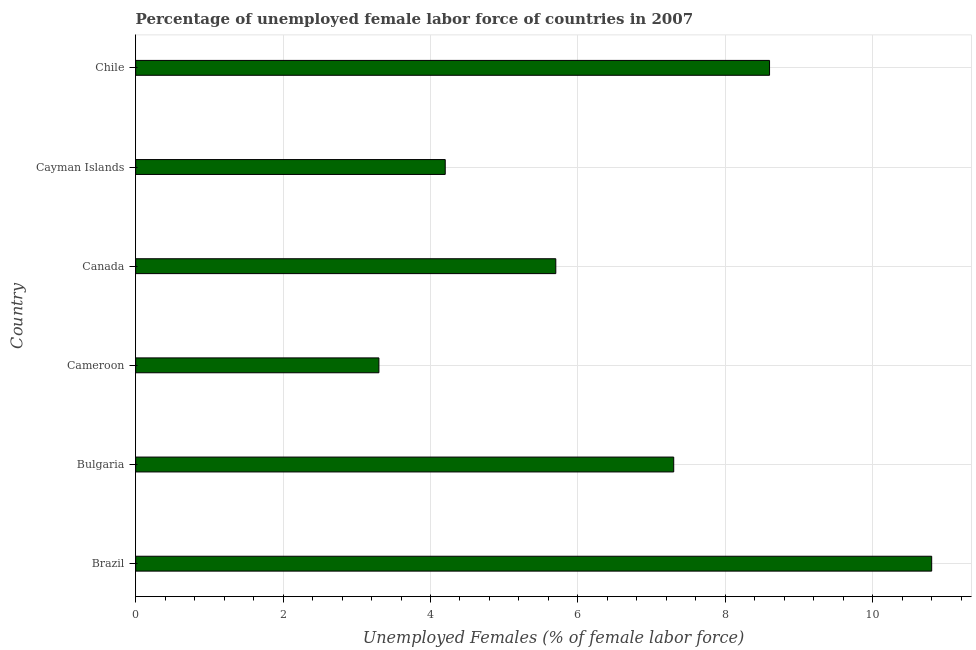Does the graph contain any zero values?
Offer a terse response. No. Does the graph contain grids?
Make the answer very short. Yes. What is the title of the graph?
Provide a succinct answer. Percentage of unemployed female labor force of countries in 2007. What is the label or title of the X-axis?
Ensure brevity in your answer.  Unemployed Females (% of female labor force). What is the label or title of the Y-axis?
Your answer should be very brief. Country. What is the total unemployed female labour force in Bulgaria?
Keep it short and to the point. 7.3. Across all countries, what is the maximum total unemployed female labour force?
Give a very brief answer. 10.8. Across all countries, what is the minimum total unemployed female labour force?
Ensure brevity in your answer.  3.3. In which country was the total unemployed female labour force maximum?
Give a very brief answer. Brazil. In which country was the total unemployed female labour force minimum?
Give a very brief answer. Cameroon. What is the sum of the total unemployed female labour force?
Ensure brevity in your answer.  39.9. What is the average total unemployed female labour force per country?
Your answer should be compact. 6.65. What is the median total unemployed female labour force?
Keep it short and to the point. 6.5. What is the ratio of the total unemployed female labour force in Bulgaria to that in Chile?
Give a very brief answer. 0.85. What is the difference between the highest and the second highest total unemployed female labour force?
Provide a succinct answer. 2.2. Is the sum of the total unemployed female labour force in Cameroon and Chile greater than the maximum total unemployed female labour force across all countries?
Provide a short and direct response. Yes. In how many countries, is the total unemployed female labour force greater than the average total unemployed female labour force taken over all countries?
Provide a short and direct response. 3. How many bars are there?
Your answer should be compact. 6. Are all the bars in the graph horizontal?
Offer a terse response. Yes. How many countries are there in the graph?
Offer a very short reply. 6. Are the values on the major ticks of X-axis written in scientific E-notation?
Offer a very short reply. No. What is the Unemployed Females (% of female labor force) in Brazil?
Your response must be concise. 10.8. What is the Unemployed Females (% of female labor force) of Bulgaria?
Provide a short and direct response. 7.3. What is the Unemployed Females (% of female labor force) of Cameroon?
Make the answer very short. 3.3. What is the Unemployed Females (% of female labor force) in Canada?
Provide a succinct answer. 5.7. What is the Unemployed Females (% of female labor force) in Cayman Islands?
Offer a very short reply. 4.2. What is the Unemployed Females (% of female labor force) of Chile?
Give a very brief answer. 8.6. What is the difference between the Unemployed Females (% of female labor force) in Brazil and Bulgaria?
Your response must be concise. 3.5. What is the difference between the Unemployed Females (% of female labor force) in Brazil and Cameroon?
Keep it short and to the point. 7.5. What is the difference between the Unemployed Females (% of female labor force) in Brazil and Cayman Islands?
Your response must be concise. 6.6. What is the difference between the Unemployed Females (% of female labor force) in Brazil and Chile?
Offer a terse response. 2.2. What is the difference between the Unemployed Females (% of female labor force) in Bulgaria and Canada?
Ensure brevity in your answer.  1.6. What is the difference between the Unemployed Females (% of female labor force) in Cameroon and Canada?
Give a very brief answer. -2.4. What is the difference between the Unemployed Females (% of female labor force) in Cameroon and Cayman Islands?
Give a very brief answer. -0.9. What is the difference between the Unemployed Females (% of female labor force) in Cameroon and Chile?
Keep it short and to the point. -5.3. What is the difference between the Unemployed Females (% of female labor force) in Canada and Cayman Islands?
Provide a succinct answer. 1.5. What is the difference between the Unemployed Females (% of female labor force) in Canada and Chile?
Offer a very short reply. -2.9. What is the difference between the Unemployed Females (% of female labor force) in Cayman Islands and Chile?
Keep it short and to the point. -4.4. What is the ratio of the Unemployed Females (% of female labor force) in Brazil to that in Bulgaria?
Offer a terse response. 1.48. What is the ratio of the Unemployed Females (% of female labor force) in Brazil to that in Cameroon?
Make the answer very short. 3.27. What is the ratio of the Unemployed Females (% of female labor force) in Brazil to that in Canada?
Offer a terse response. 1.9. What is the ratio of the Unemployed Females (% of female labor force) in Brazil to that in Cayman Islands?
Offer a very short reply. 2.57. What is the ratio of the Unemployed Females (% of female labor force) in Brazil to that in Chile?
Provide a short and direct response. 1.26. What is the ratio of the Unemployed Females (% of female labor force) in Bulgaria to that in Cameroon?
Your answer should be very brief. 2.21. What is the ratio of the Unemployed Females (% of female labor force) in Bulgaria to that in Canada?
Your response must be concise. 1.28. What is the ratio of the Unemployed Females (% of female labor force) in Bulgaria to that in Cayman Islands?
Your response must be concise. 1.74. What is the ratio of the Unemployed Females (% of female labor force) in Bulgaria to that in Chile?
Make the answer very short. 0.85. What is the ratio of the Unemployed Females (% of female labor force) in Cameroon to that in Canada?
Your answer should be very brief. 0.58. What is the ratio of the Unemployed Females (% of female labor force) in Cameroon to that in Cayman Islands?
Make the answer very short. 0.79. What is the ratio of the Unemployed Females (% of female labor force) in Cameroon to that in Chile?
Your answer should be compact. 0.38. What is the ratio of the Unemployed Females (% of female labor force) in Canada to that in Cayman Islands?
Offer a very short reply. 1.36. What is the ratio of the Unemployed Females (% of female labor force) in Canada to that in Chile?
Ensure brevity in your answer.  0.66. What is the ratio of the Unemployed Females (% of female labor force) in Cayman Islands to that in Chile?
Keep it short and to the point. 0.49. 